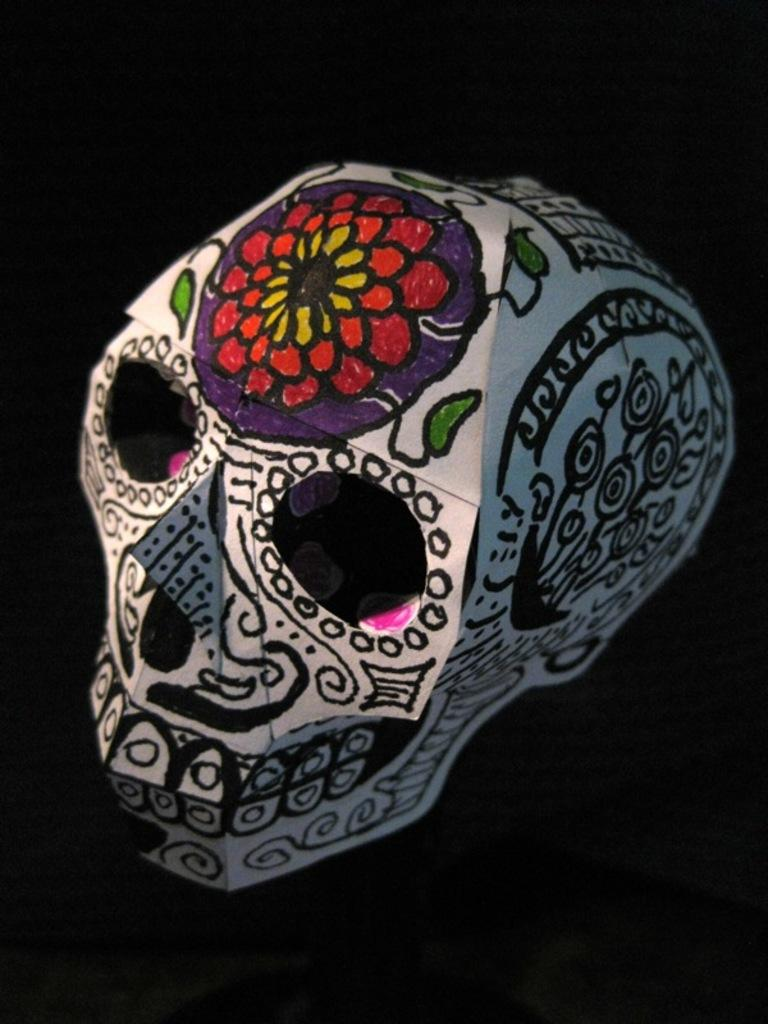What is the main subject of the image? The main subject of the image is a skull. What is placed on the skull? There are rangolis and drawings on the skull. How would you describe the background of the image? The background of the image is dark. How much money is the porter carrying in the image? There is no porter or money present in the image; it features a skull with rangolis and drawings. 